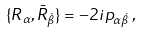<formula> <loc_0><loc_0><loc_500><loc_500>\{ R _ { \alpha } , \bar { R } _ { \dot { \beta } } \} = - 2 i p _ { \alpha \dot { \beta } } \, ,</formula> 